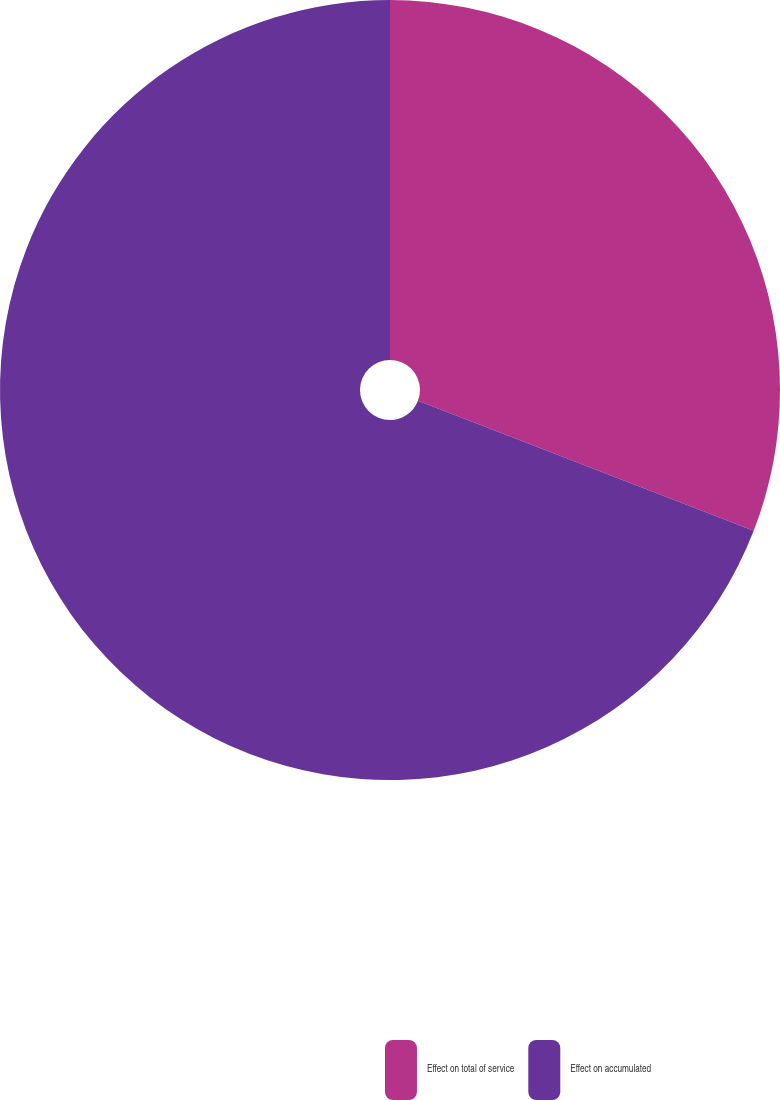Convert chart to OTSL. <chart><loc_0><loc_0><loc_500><loc_500><pie_chart><fcel>Effect on total of service<fcel>Effect on accumulated<nl><fcel>30.88%<fcel>69.12%<nl></chart> 